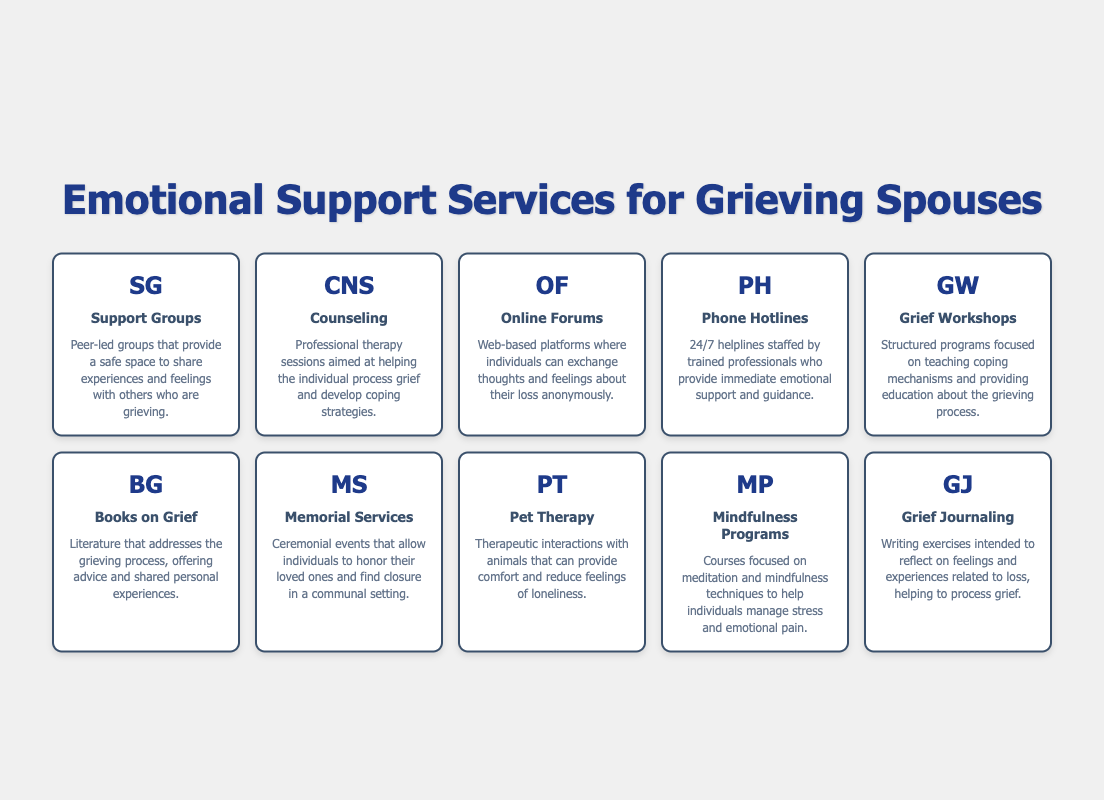What is the main purpose of Support Groups? The table indicates that Support Groups provide a safe space for individuals to share experiences and feelings with others who are grieving. This aligns with the description given for this service.
Answer: To share experiences and feelings Which service offers therapy sessions to process grief? Referring to the table, Counseling is described as professional therapy sessions aimed at helping the individual process grief and develop coping strategies, confirming this service's purpose.
Answer: Counseling How many services are focused on learning coping mechanisms? The table lists Grief Workshops and Mindfulness Programs as services aimed at teaching coping mechanisms. By counting these two, we confirm that there are two services designed for this purpose.
Answer: 2 Are online forums a source for grief support? The table specifies that Online Forums are web-based platforms where individuals can exchange thoughts and feelings about their loss anonymously. This confirms that online forums indeed provide a form of grief support.
Answer: Yes What type of service is designed to help reduce feelings of loneliness? Pet Therapy is the service in the table that focuses on therapeutic interactions with animals to provide comfort and reduce loneliness, as described.
Answer: Pet Therapy What is the difference between Grief Workshops and Books on Grief in terms of their focus? Grief Workshops are structured programs aimed at teaching coping mechanisms, while Books on Grief are literature that offers advice and shared experiences. The difference lies in the interactive, educational nature of workshops versus the passive reading experience of books.
Answer: Workshops focus on teaching; books offer advice Which two services are available for immediate emotional support? The Next step involves identifying services for immediate support, and from the table, we see Phone Hotlines provide 24/7 help, while Support Groups allow for sharing experiences. Thus, the two services are Phone Hotlines and Support Groups.
Answer: Phone Hotlines and Support Groups What kind of assistance does Grief Journaling provide? Grief Journaling involves writing exercises intended to reflect on feelings and experiences related to loss, helping individuals process grief. This descriptive element helps clarify the assistance provided by this service.
Answer: Assistance in processing grief Which service allows people to honor their loved ones? The service named Memorial Services in the table is specifically stated as allowing individuals to honor their loved ones and find closure, making it clear that this service fulfills that need.
Answer: Memorial Services 